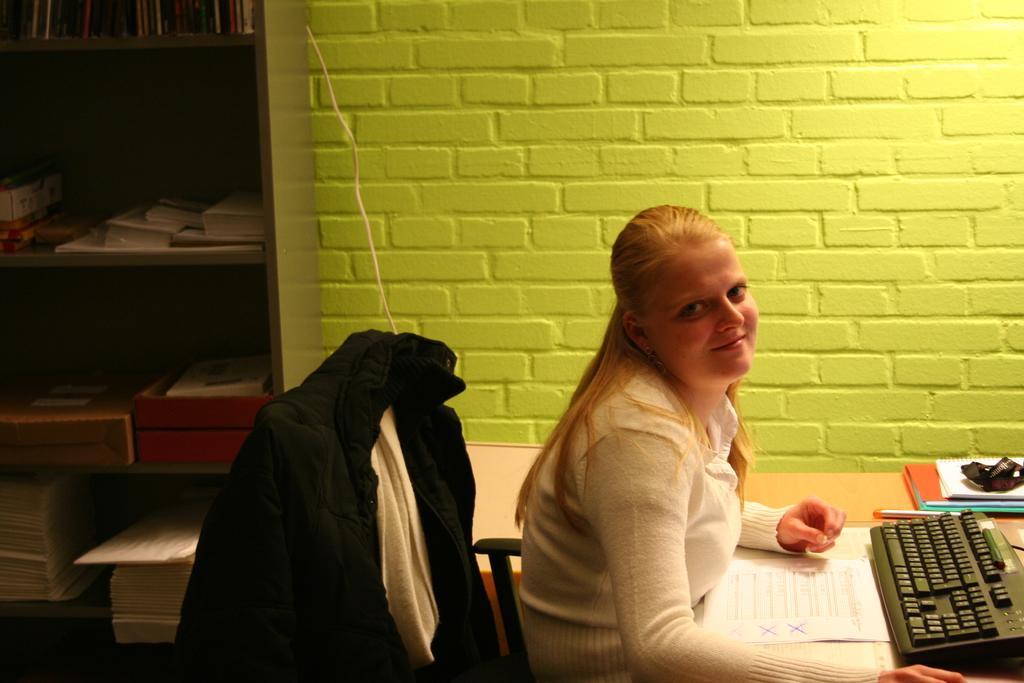How would you summarize this image in a sentence or two? In this picture, we can see the wall and shelves with some objects in it, we can see a lady sitting in a chair, and resting her hands on the table we can see some objects on table like keyboard, books and papers. 